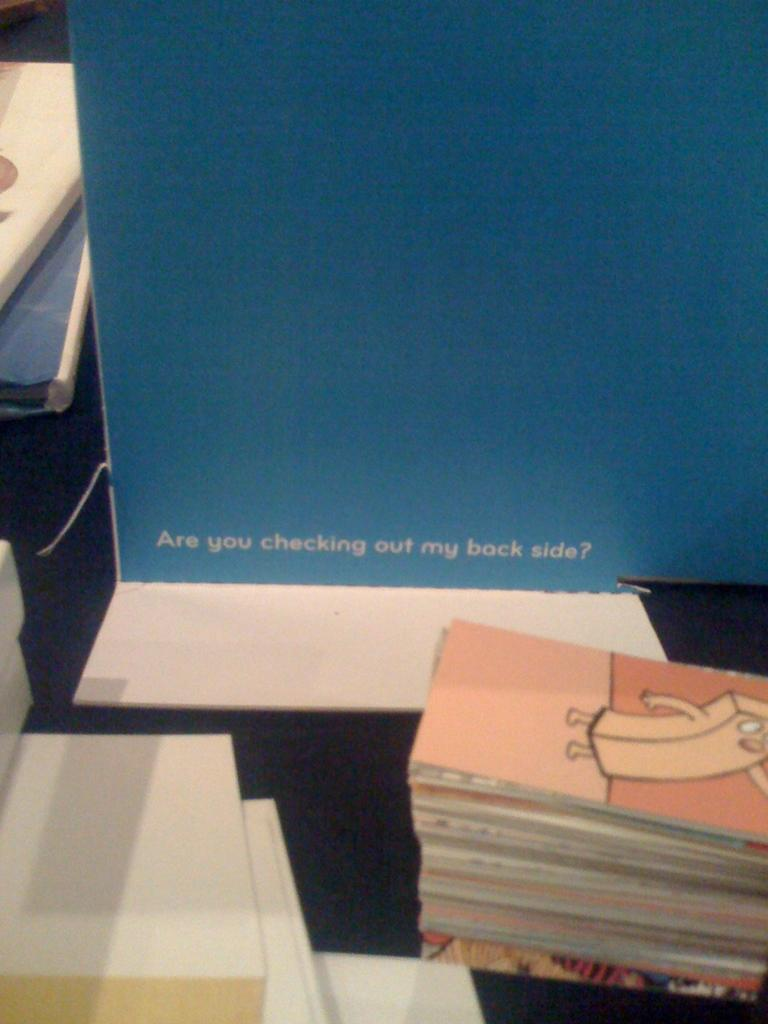<image>
Give a short and clear explanation of the subsequent image. A cardboard panel on a table or desk reads "Are you checking out my back side?" 